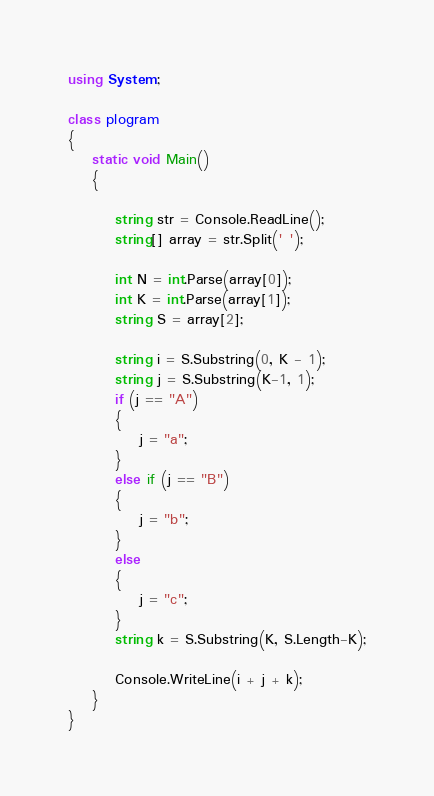Convert code to text. <code><loc_0><loc_0><loc_500><loc_500><_C#_>using System;

class plogram
{
    static void Main()
    {

        string str = Console.ReadLine();
        string[] array = str.Split(' ');

        int N = int.Parse(array[0]);
        int K = int.Parse(array[1]);
        string S = array[2];

        string i = S.Substring(0, K - 1);
        string j = S.Substring(K-1, 1);
        if (j == "A")
        {
            j = "a";
        }
        else if (j == "B")
        {
            j = "b";
        }
        else
        {
            j = "c";
        }
        string k = S.Substring(K, S.Length-K);

        Console.WriteLine(i + j + k);
    }
}</code> 